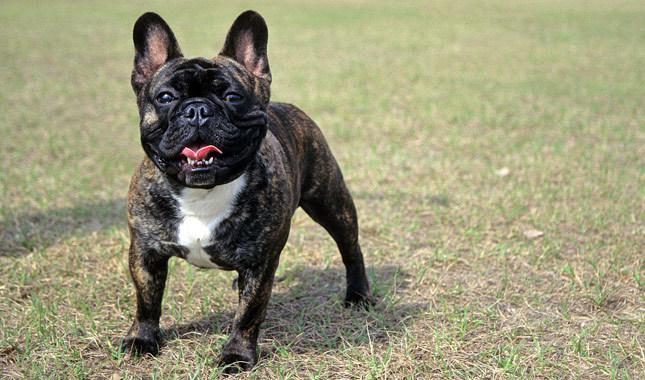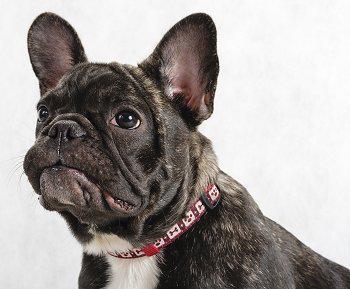The first image is the image on the left, the second image is the image on the right. Given the left and right images, does the statement "All of the dogs are dark colored, and the right image contains twice the dogs as the left image." hold true? Answer yes or no. No. The first image is the image on the left, the second image is the image on the right. For the images displayed, is the sentence "There are two dogs in the grass." factually correct? Answer yes or no. No. 